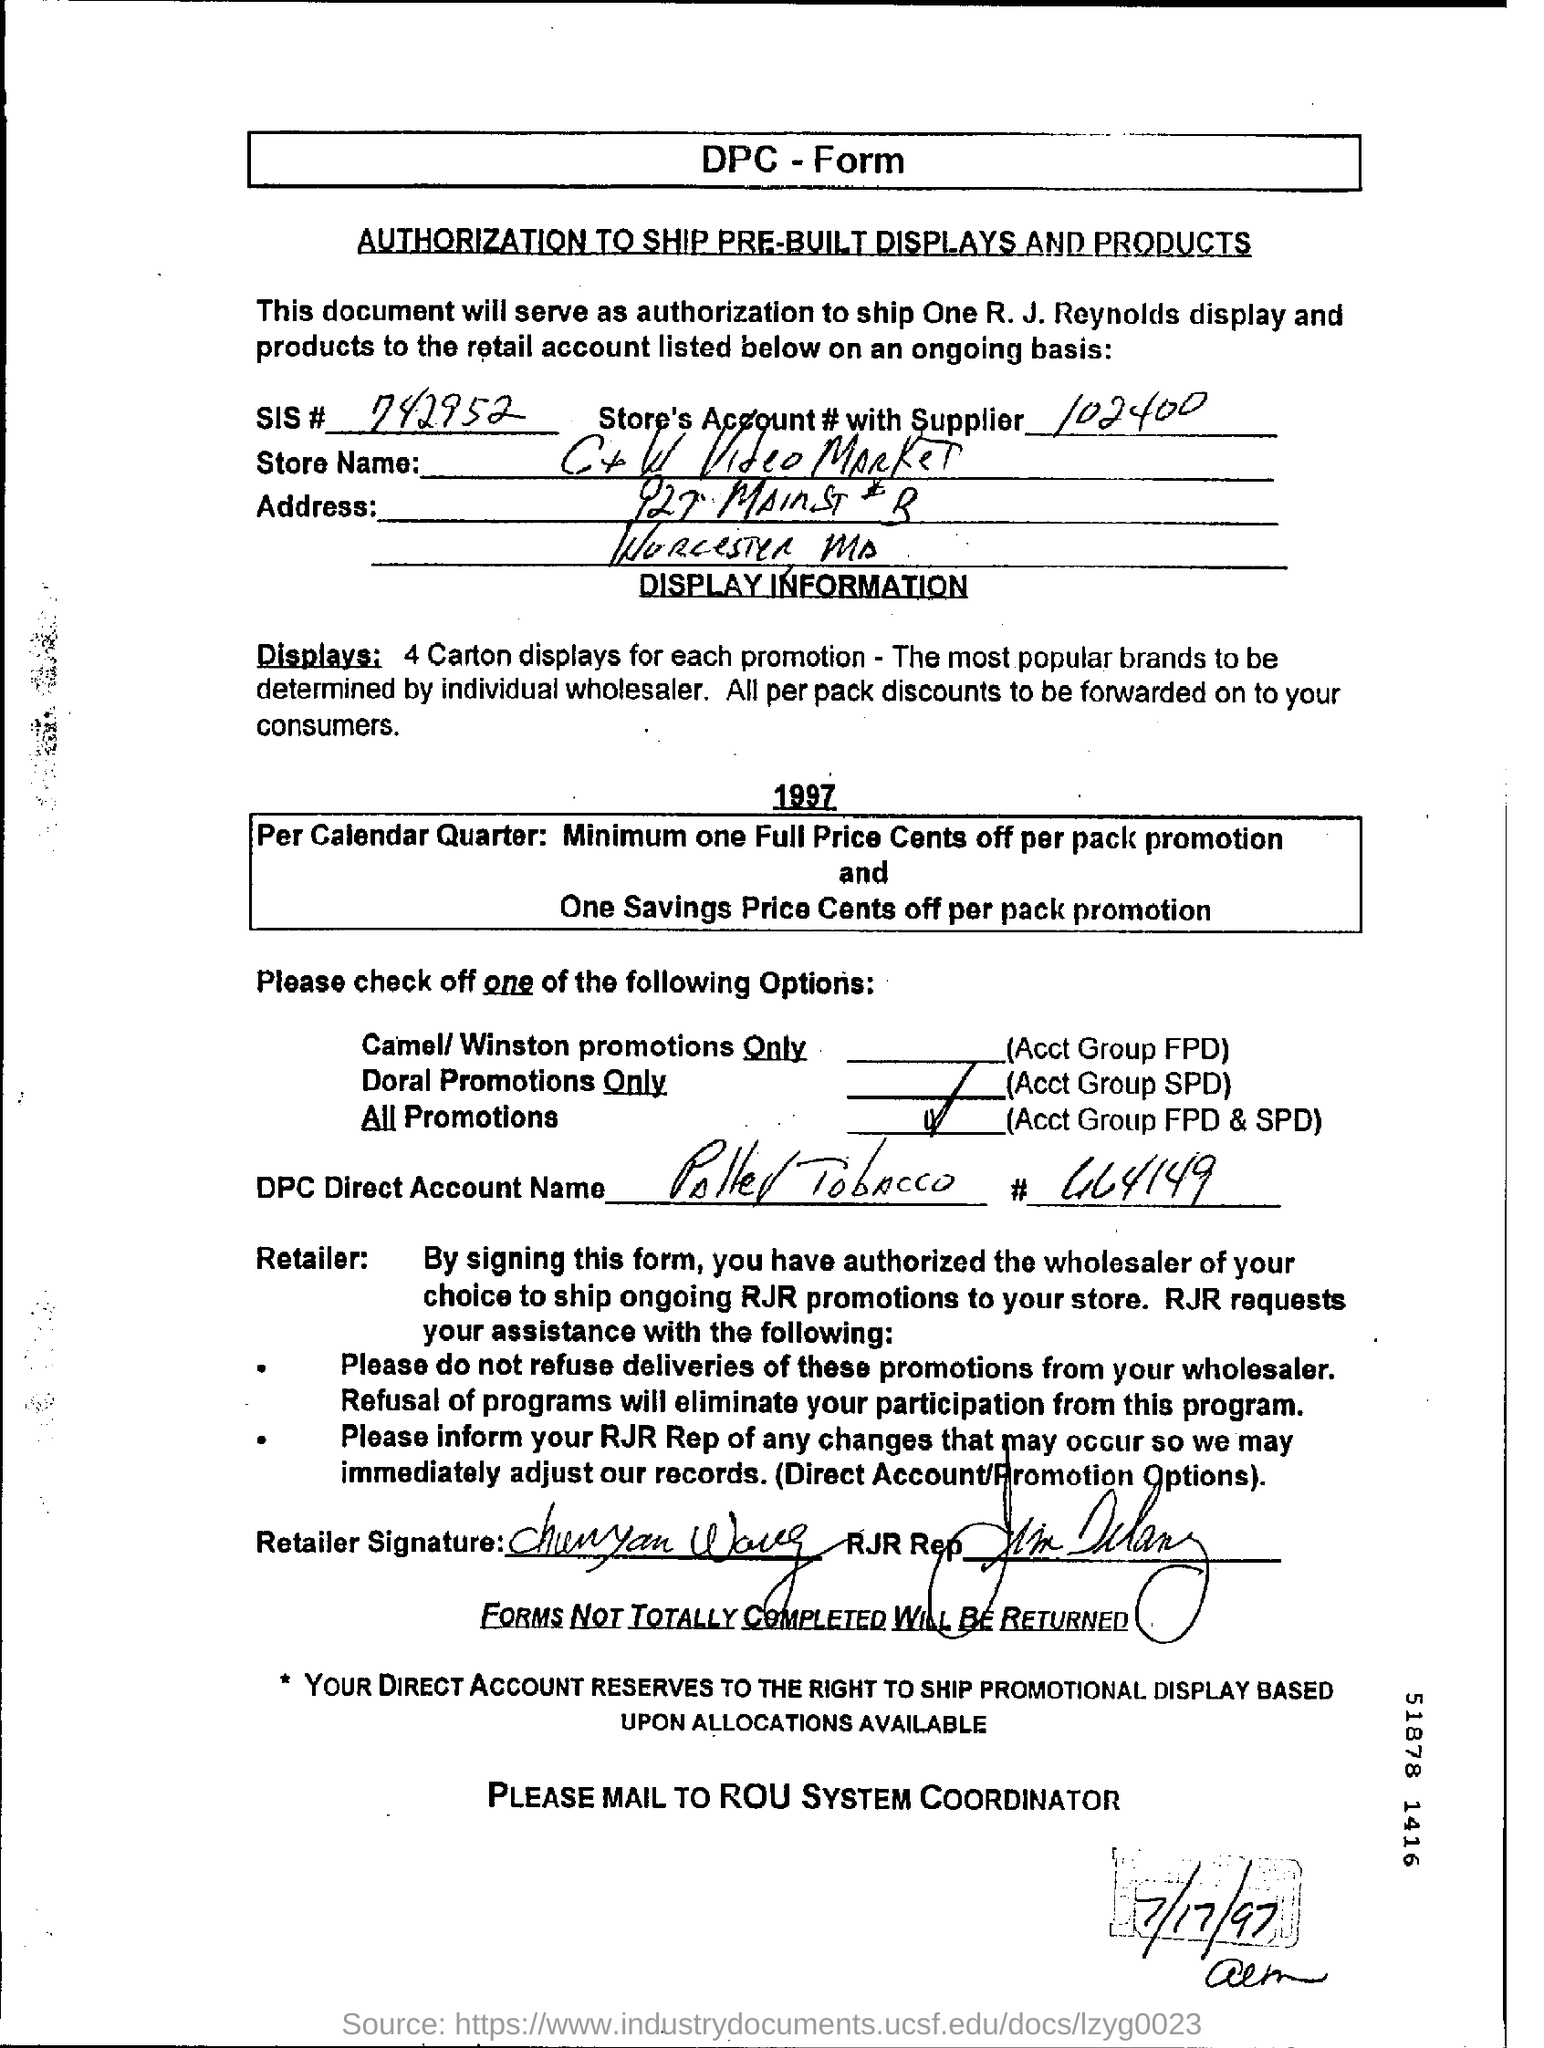What is SIS # given in the form?
Offer a terse response. 742952. What is the Store's Account # with supplier given in the form?
Provide a succinct answer. 102400. What is the date mentioned in this form?
Your response must be concise. 7/17/97. 